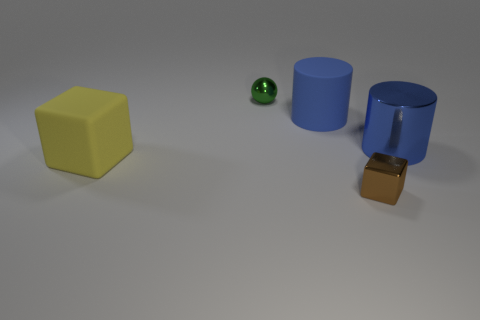Add 5 tiny green metallic objects. How many objects exist? 10 Subtract all cylinders. How many objects are left? 3 Subtract 0 cyan cylinders. How many objects are left? 5 Subtract all rubber cylinders. Subtract all blue cylinders. How many objects are left? 2 Add 2 green spheres. How many green spheres are left? 3 Add 5 large blue cylinders. How many large blue cylinders exist? 7 